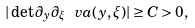<formula> <loc_0><loc_0><loc_500><loc_500>| \det \partial _ { y } \partial _ { \xi } \ v a ( y , \xi ) | \geq C > 0 ,</formula> 